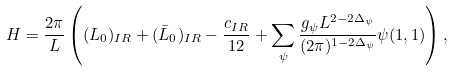Convert formula to latex. <formula><loc_0><loc_0><loc_500><loc_500>H = \frac { 2 \pi } { L } \left ( ( L _ { 0 } ) _ { I R } + ( \bar { L } _ { 0 } ) _ { I R } - \frac { c _ { I R } } { 1 2 } + \sum _ { \psi } \frac { g _ { \psi } L ^ { 2 - 2 \Delta _ { \psi } } } { ( 2 \pi ) ^ { 1 - 2 \Delta _ { \psi } } } \psi ( 1 , 1 ) \right ) ,</formula> 